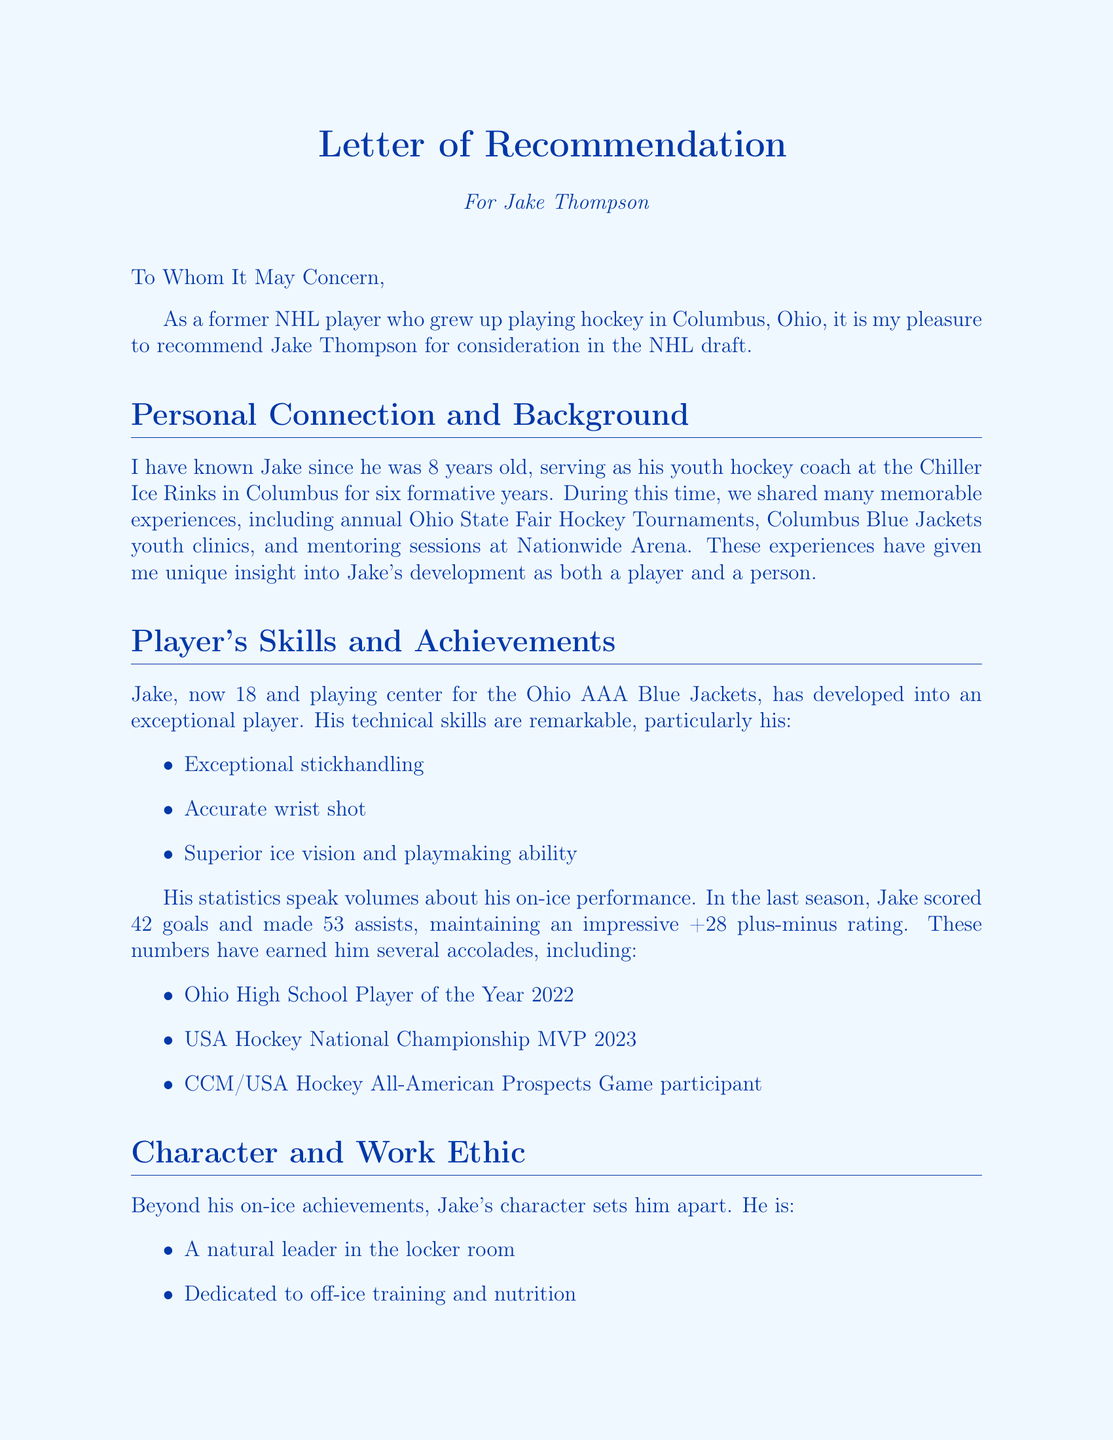What is the name of the player being recommended? The document clearly states that the player being recommended is Jake Thompson.
Answer: Jake Thompson What is Jake Thompson's position? The letter mentions that Jake plays the position of Center for his current team.
Answer: Center How many goals did Jake score last season? The document lists Jake's scoring statistics, revealing that he scored 42 goals last season.
Answer: 42 What award did Jake win in 2022? The document highlights Jake's achievements, specifically naming him the Ohio High School Player of the Year in 2022.
Answer: Ohio High School Player of the Year 2022 Who is the recommender of this letter? The letter identifies the recommender as Mike Johnson, who is a former NHL player and currently works for the Columbus Blue Jackets.
Answer: Mike Johnson In what year did Mike Johnson play in the NHL? The document notes that Mike Johnson played in the NHL from 2005 to 2015.
Answer: 2005-2015 What is Jake's projected role in the NHL? The letter states that Jake is projected to be a top-six forward with potential for special teams play.
Answer: Top-six forward with potential for special teams play What technical skill is Jake known for besides his wrist shot? The document outlines Jake's technical skills, including exceptional stickhandling and superior ice vision and playmaking ability.
Answer: Exceptional stickhandling What organization is Mike Johnson currently affiliated with? The letter specifies that Mike Johnson is the Director of Player Development for the Columbus Blue Jackets.
Answer: Columbus Blue Jackets 